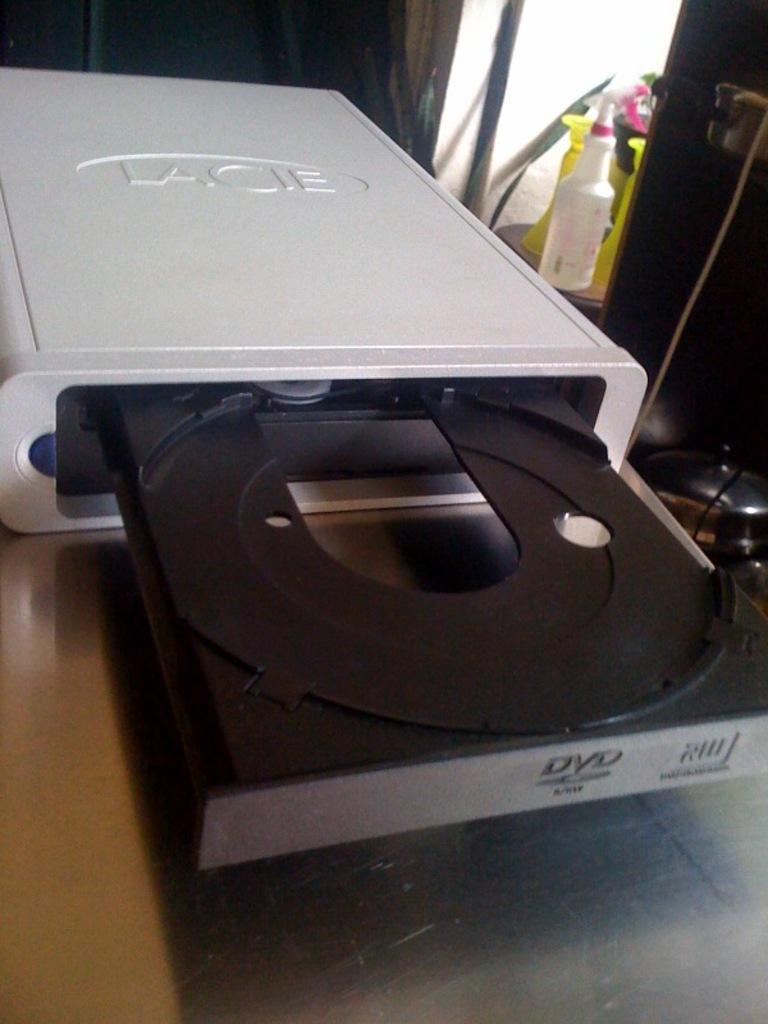Provide a one-sentence caption for the provided image. An open dvd player is from the brand Lacie. 